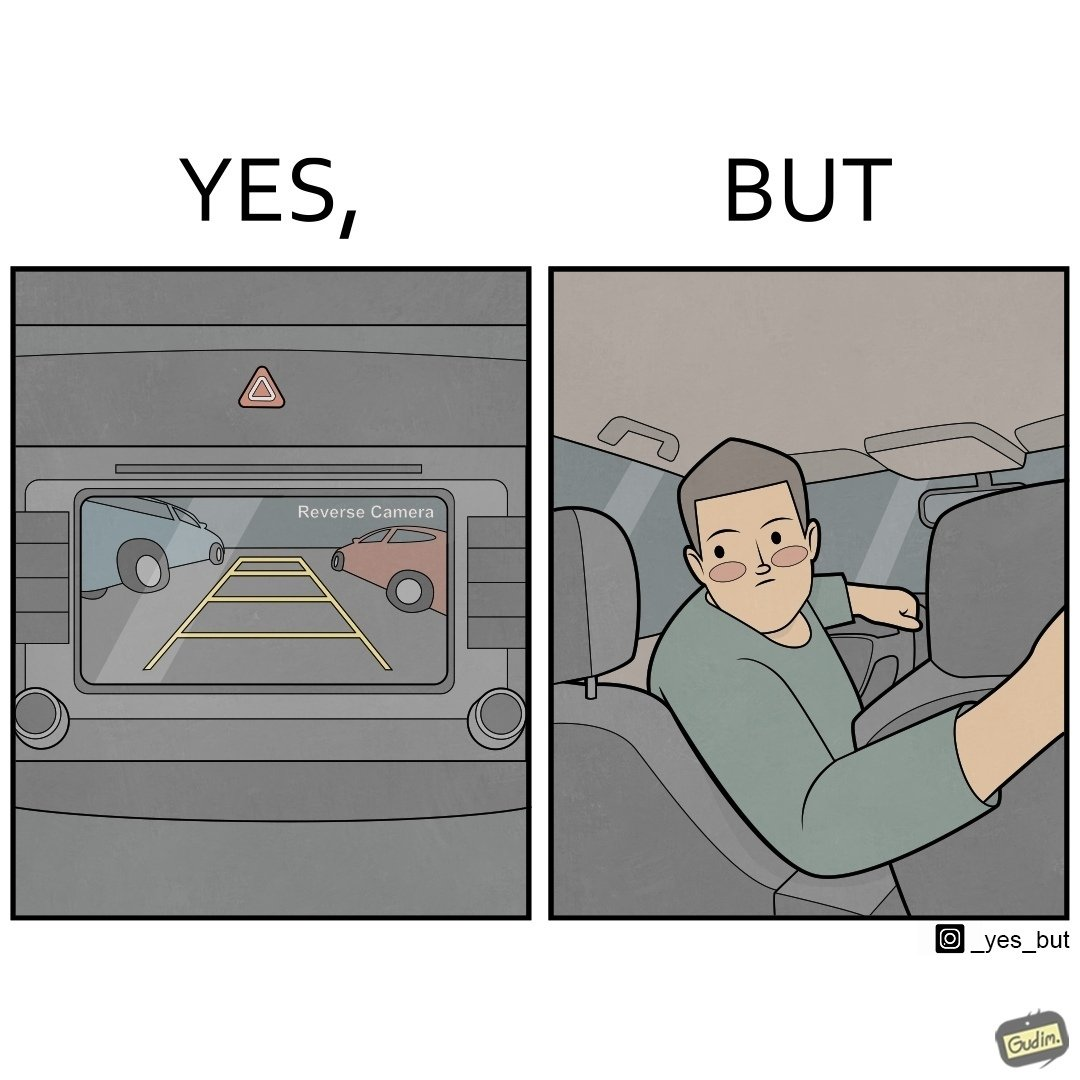What do you see in each half of this image? In the left part of the image: It is a view of a vehicles rear end as seen by a reverse camera being projected onto a screen In the right part of the image: It is a man in his car looking back to ensure he is reversing his car safely 